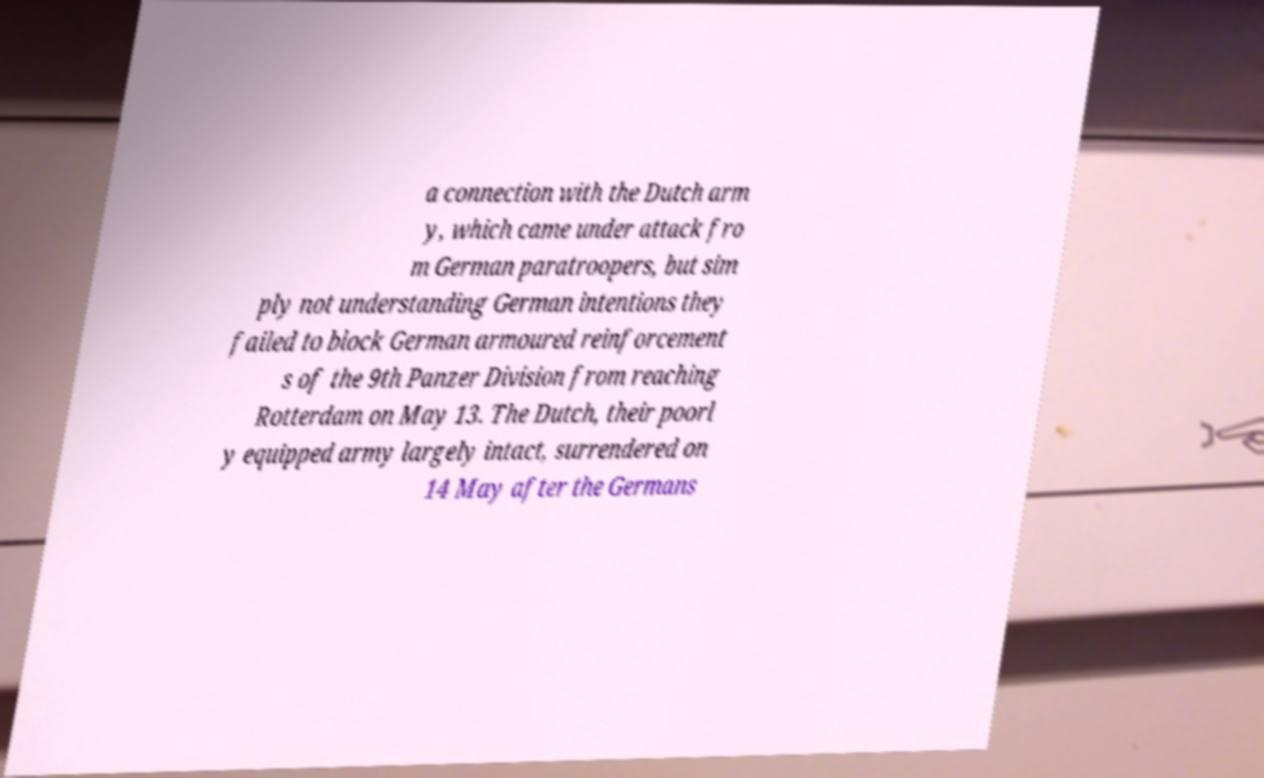Please identify and transcribe the text found in this image. a connection with the Dutch arm y, which came under attack fro m German paratroopers, but sim ply not understanding German intentions they failed to block German armoured reinforcement s of the 9th Panzer Division from reaching Rotterdam on May 13. The Dutch, their poorl y equipped army largely intact, surrendered on 14 May after the Germans 